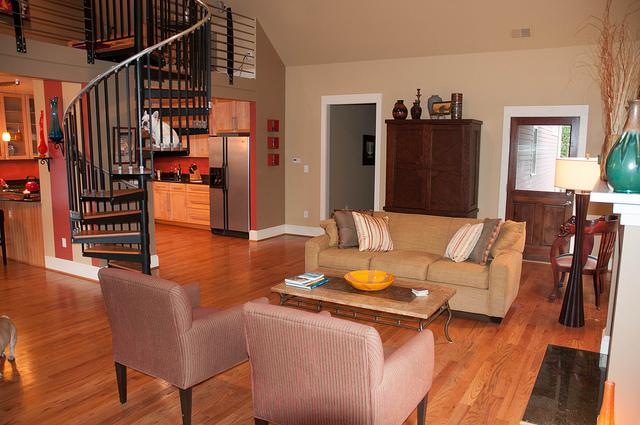What gives the square items on the couch their shape? Please explain your reasoning. stuffing. That's how they make pillows. 